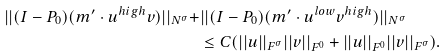<formula> <loc_0><loc_0><loc_500><loc_500>| | ( I - P _ { 0 } ) ( m ^ { \prime } \cdot u ^ { h i g h } v ) | | _ { N ^ { \sigma } } + & | | ( I - P _ { 0 } ) ( m ^ { \prime } \cdot u ^ { l o w } v ^ { h i g h } ) | | _ { N ^ { \sigma } } \\ & \leq C ( | | u | | _ { F ^ { \sigma } } | | v | | _ { F ^ { 0 } } + | | u | | _ { F ^ { 0 } } | | v | | _ { F ^ { \sigma } } ) .</formula> 